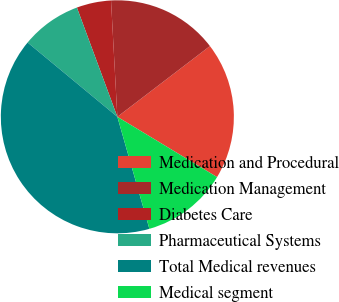Convert chart. <chart><loc_0><loc_0><loc_500><loc_500><pie_chart><fcel>Medication and Procedural<fcel>Medication Management<fcel>Diabetes Care<fcel>Pharmaceutical Systems<fcel>Total Medical revenues<fcel>Medical segment<nl><fcel>19.04%<fcel>15.48%<fcel>4.78%<fcel>8.35%<fcel>40.44%<fcel>11.91%<nl></chart> 